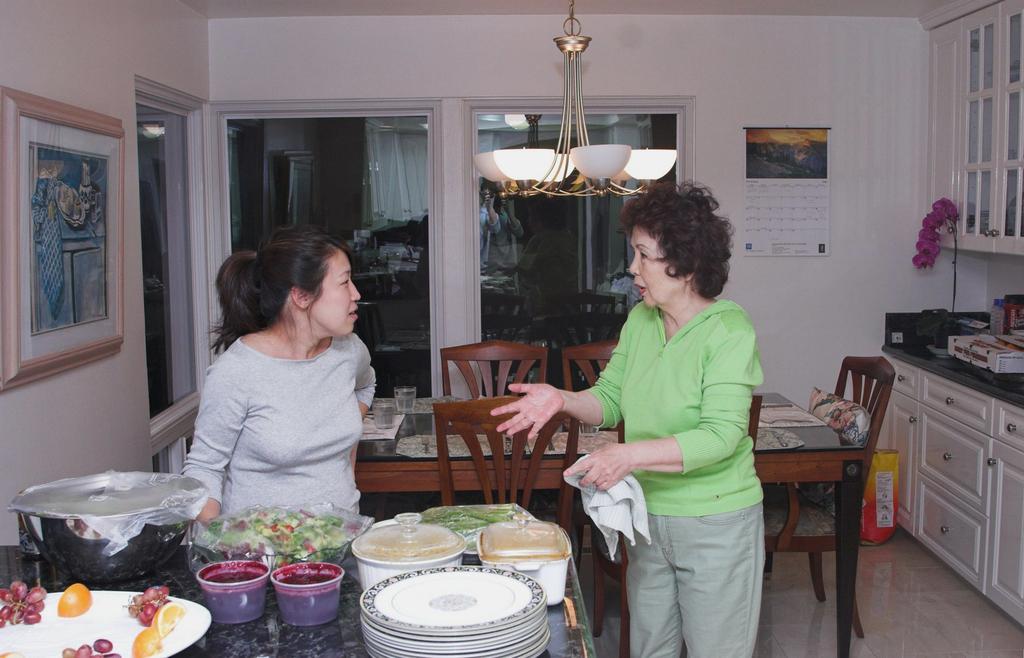Describe this image in one or two sentences. In this image I can see few people. In front I can see few plates, food items, fruits, vessels, glasses and few objects on the tables. I can see the cupboards, glass windows, frame and calendar are attached to the wall. I can see few objects on the cupboard. 